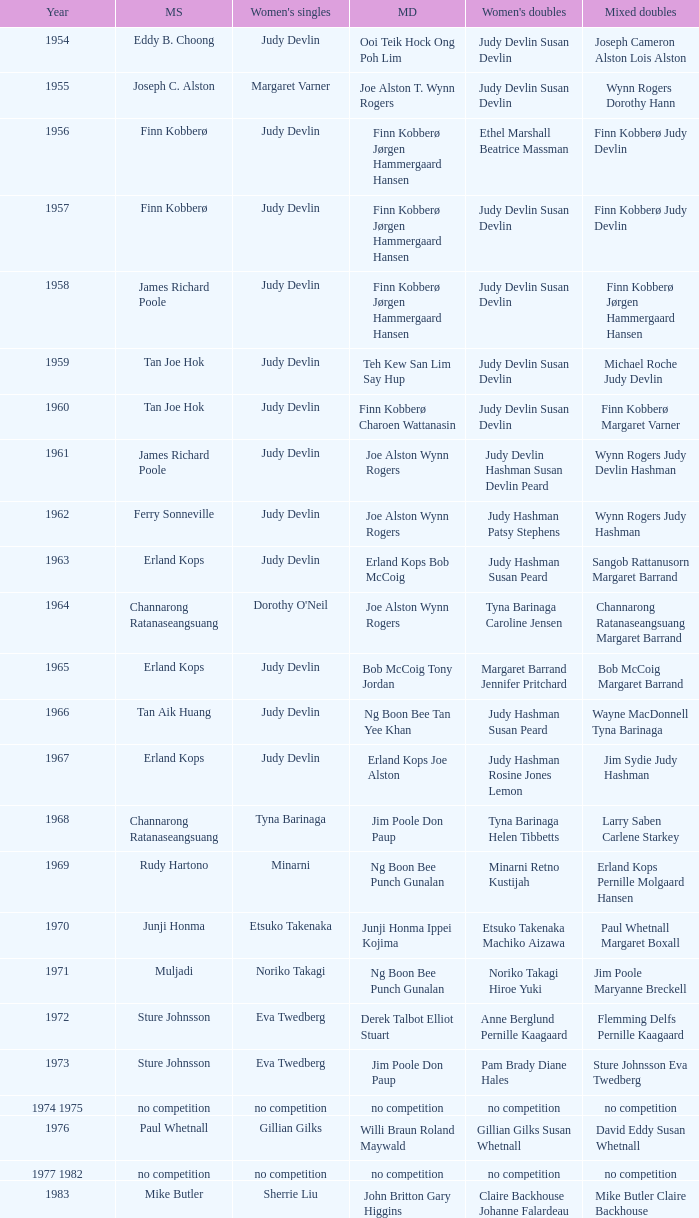Who was the women's singles champion in 1984? Luo Yun. 